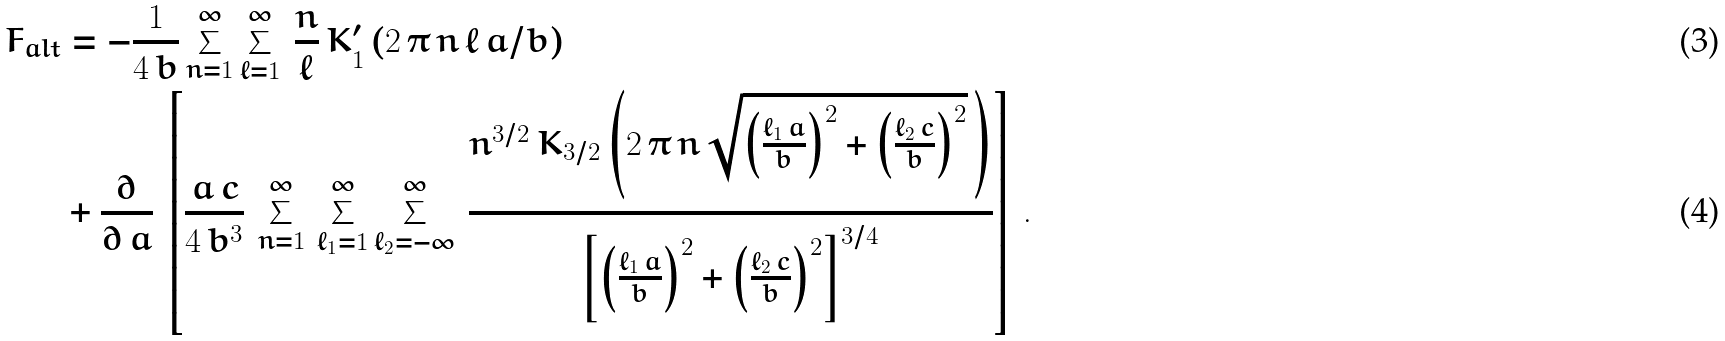Convert formula to latex. <formula><loc_0><loc_0><loc_500><loc_500>F _ { a l t } & = - \frac { 1 } { 4 \, b } \sum _ { n = 1 } ^ { \infty } \sum _ { \ell = 1 } ^ { \infty } \, \frac { n } { \ell } \, K _ { 1 } ^ { \prime } \left ( 2 \, \pi \, n \, \ell \, a / b \right ) \\ & + \frac { \partial } { \partial \, a } \, \left [ \frac { a \, c } { 4 \, b ^ { 3 } } \, \sum _ { n = 1 } ^ { \infty } \, \sum _ { \ell _ { 1 } = 1 } ^ { \infty } \sum _ { \ell _ { 2 } = - \infty } ^ { \infty } \, \frac { n ^ { 3 / 2 } \, K _ { 3 / 2 } \left ( 2 \, \pi \, n \, \sqrt { \left ( \frac { \ell _ { 1 } \, a } { b } \right ) ^ { 2 } + \left ( \frac { \ell _ { 2 } \, c } { b } \right ) ^ { 2 } } \, \right ) } { \left [ \left ( \frac { \ell _ { 1 } \, a } { b } \right ) ^ { 2 } + \left ( \frac { \ell _ { 2 } \, c } { b } \right ) ^ { 2 } \right ] ^ { 3 / 4 } } \right ] \, .</formula> 